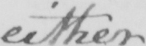What does this handwritten line say? either 